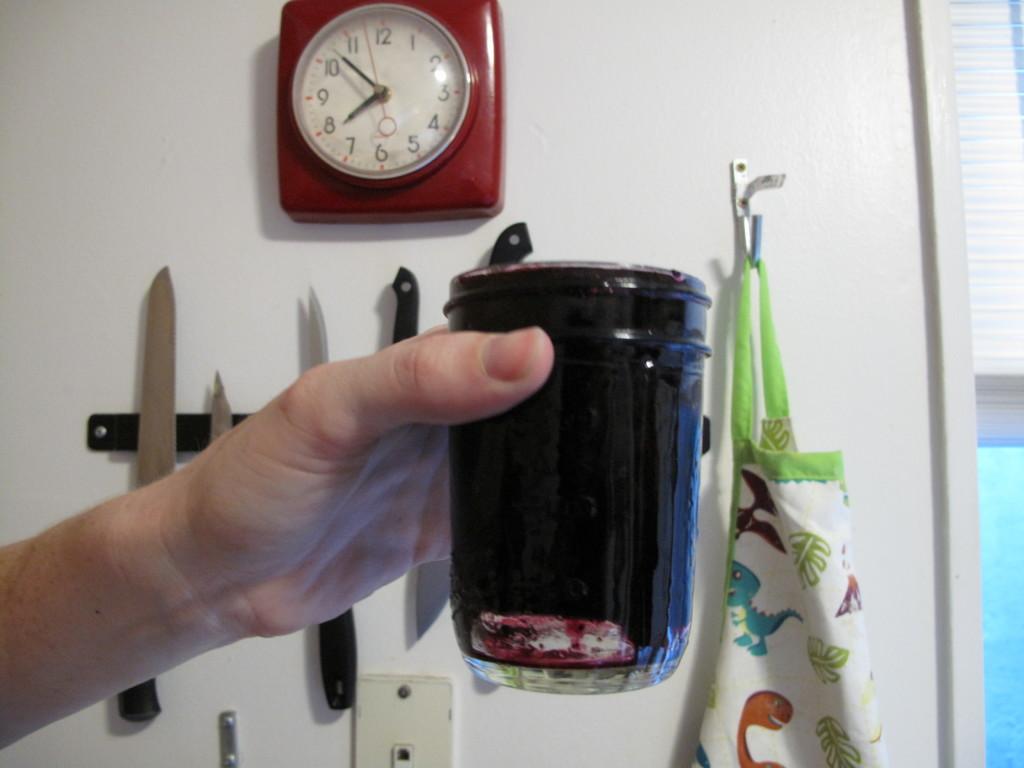What time is shown on the clock?
Your answer should be compact. 7:53. 